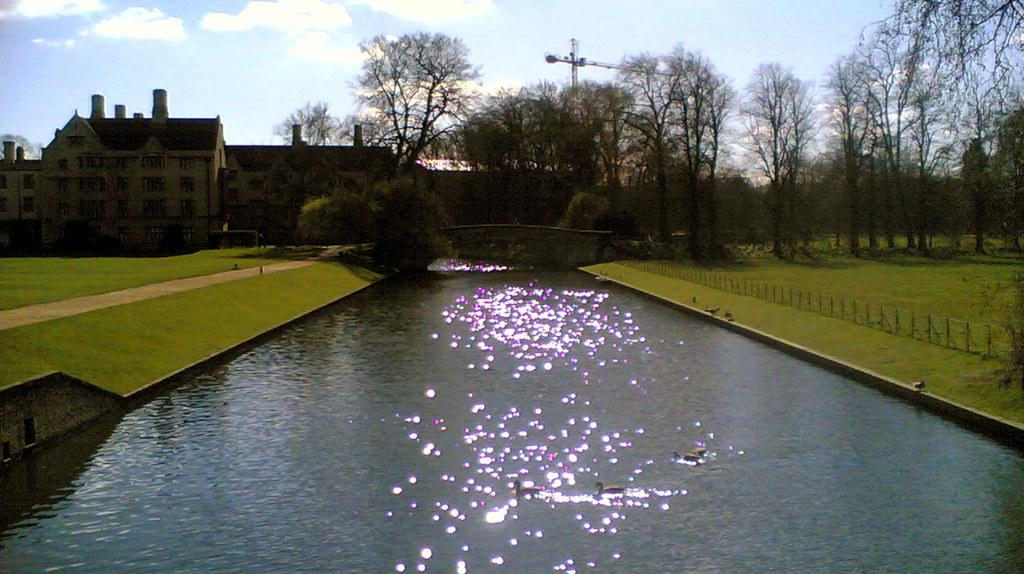What is the primary element in the image? There is water in the image, with ducks floating on it. What structures can be seen in the image? There is a bridge and a building in the image. What type of vegetation is present in the image? Grass and trees are visible in the image. What is the weather like in the image? The sky is visible in the background of the image, with clouds present. What additional object can be seen in the image? A crane is present in the image. What type of humor can be seen in the image? There is no humor present in the image; it is a scene of water, ducks, a bridge, building, grass, trees, and a crane. What direction are the bricks facing in the image? There are no bricks present in the image. 